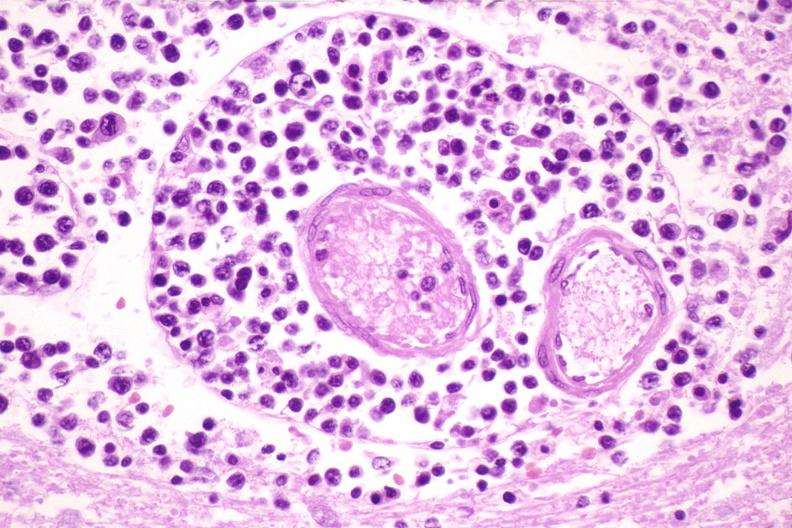what is present?
Answer the question using a single word or phrase. Nervous 